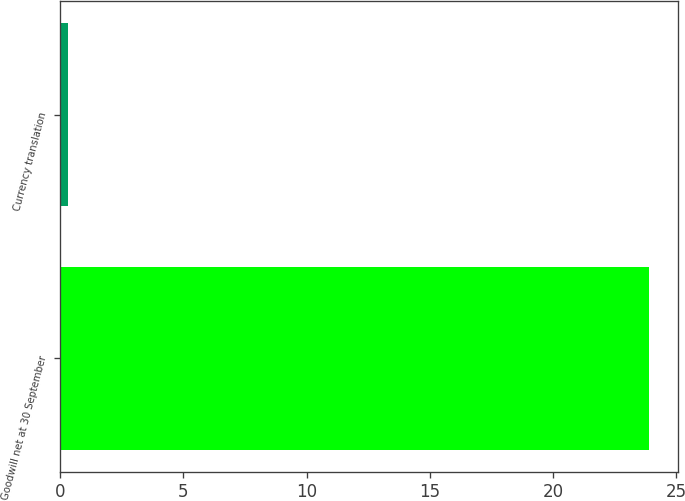<chart> <loc_0><loc_0><loc_500><loc_500><bar_chart><fcel>Goodwill net at 30 September<fcel>Currency translation<nl><fcel>23.88<fcel>0.3<nl></chart> 